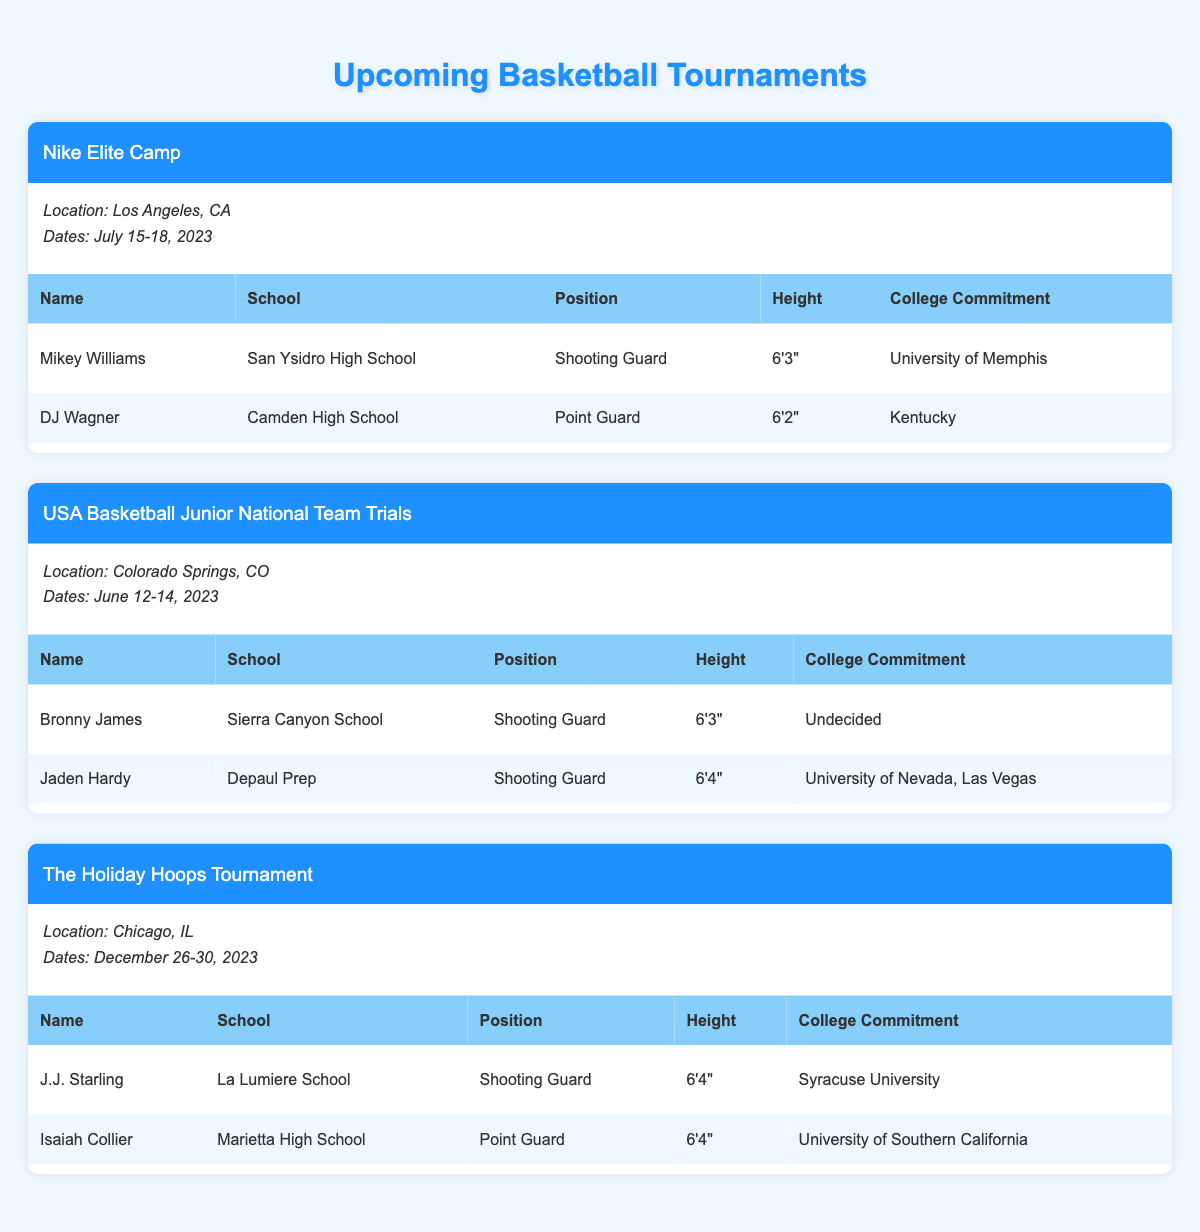What is the location of the Nike Elite Camp? The table specifies the location of the Nike Elite Camp, which is clearly stated as Los Angeles, CA.
Answer: Los Angeles, CA How many players are listed under the USA Basketball Junior National Team Trials? The table shows that there are two players listed under the USA Basketball Junior National Team Trials: Bronny James and Jaden Hardy.
Answer: 2 What is the height of DJ Wagner? In the table, DJ Wagner's height is indicated as 6'2".
Answer: 6'2" Which tournament takes place last in the year 2023? The table details the dates for each tournament, showing that The Holiday Hoops Tournament takes place from December 26-30, 2023, making it the last tournament of the year.
Answer: The Holiday Hoops Tournament Is Mikey Williams committed to a college? According to the table, Mikey Williams is committed to the University of Memphis. This indicates that he is indeed committed to a college.
Answer: Yes Which two positions are mentioned for the top prospects across all tournaments? By reviewing the table, the two positions listed for the top prospects are Shooting Guard and Point Guard.
Answer: Shooting Guard and Point Guard What is the average height of the top prospects listed in the Nike Elite Camp? The heights of the top prospects at the Nike Elite Camp are 6'3" for Mikey Williams and 6'2" for DJ Wagner. Converting these to inches, we have 75 inches and 74 inches respectively. The average height is (75 + 74) / 2 = 74.5 inches.
Answer: 74.5 inches Which player has the tallest height and what is that height? By examining the table, Jaden Hardy has the tallest height of 6'4", which is confirmed when comparing all players listed.
Answer: 6'4" What is the college commitment of Isaiah Collier? According to the table, Isaiah Collier is committed to the University of Southern California.
Answer: University of Southern California Are there more players committed to colleges or those who are undecided across all tournaments? The table shows 6 players total: 4 are committed to various colleges and 2 (Bronny James and Mikey Williams) are undecided. Therefore, there are more committed players (4) than undecided players (2).
Answer: More players are committed How many of the players are 6'4" or taller, and which players are they? The heights listed in the table show that Jaden Hardy and Isaiah Collier are both 6'4". Thus, there are 2 players who are 6'4" or taller.
Answer: 2 players: Jaden Hardy and Isaiah Collier 